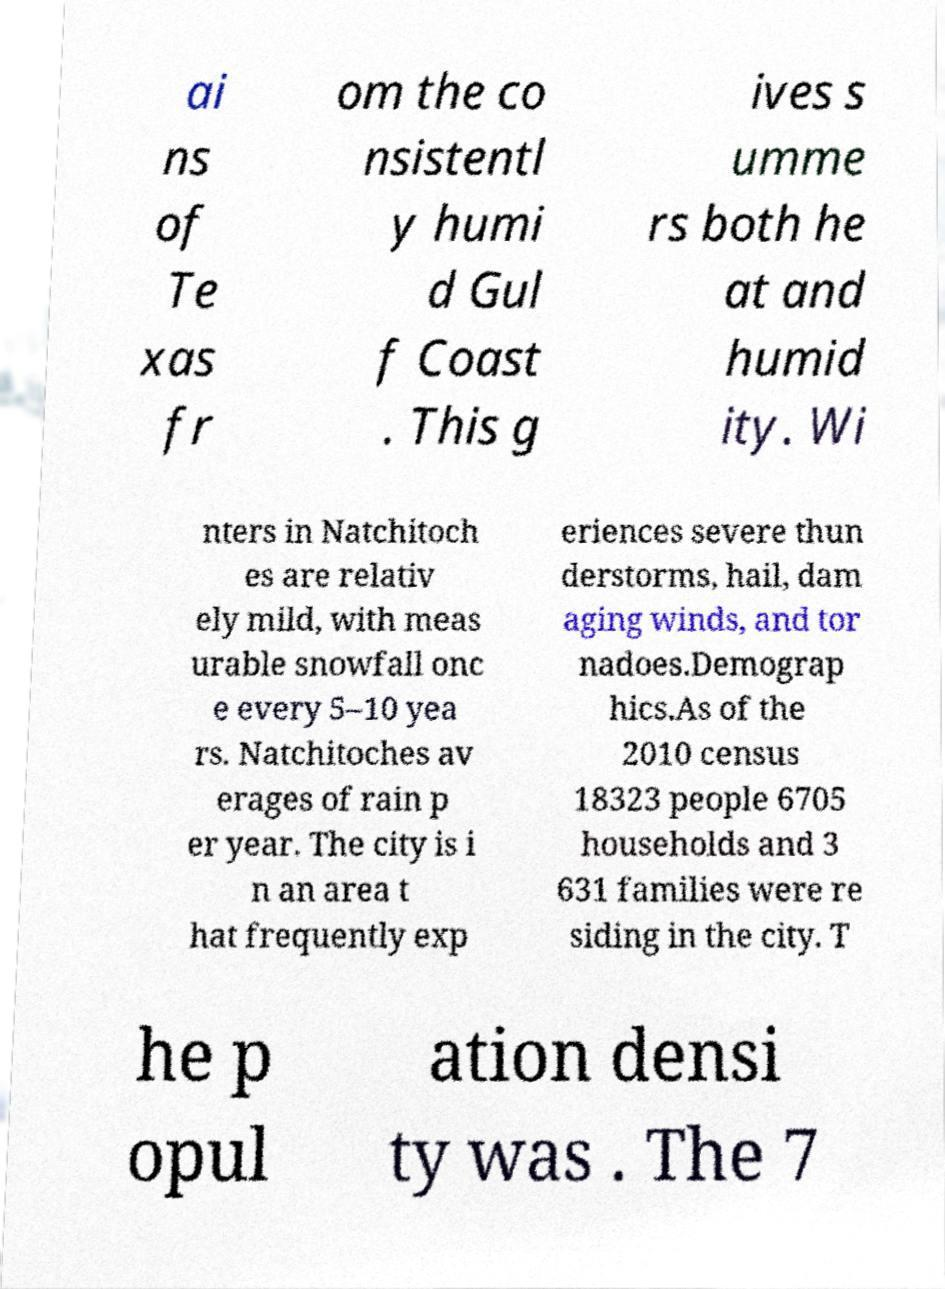Can you read and provide the text displayed in the image?This photo seems to have some interesting text. Can you extract and type it out for me? ai ns of Te xas fr om the co nsistentl y humi d Gul f Coast . This g ives s umme rs both he at and humid ity. Wi nters in Natchitoch es are relativ ely mild, with meas urable snowfall onc e every 5–10 yea rs. Natchitoches av erages of rain p er year. The city is i n an area t hat frequently exp eriences severe thun derstorms, hail, dam aging winds, and tor nadoes.Demograp hics.As of the 2010 census 18323 people 6705 households and 3 631 families were re siding in the city. T he p opul ation densi ty was . The 7 